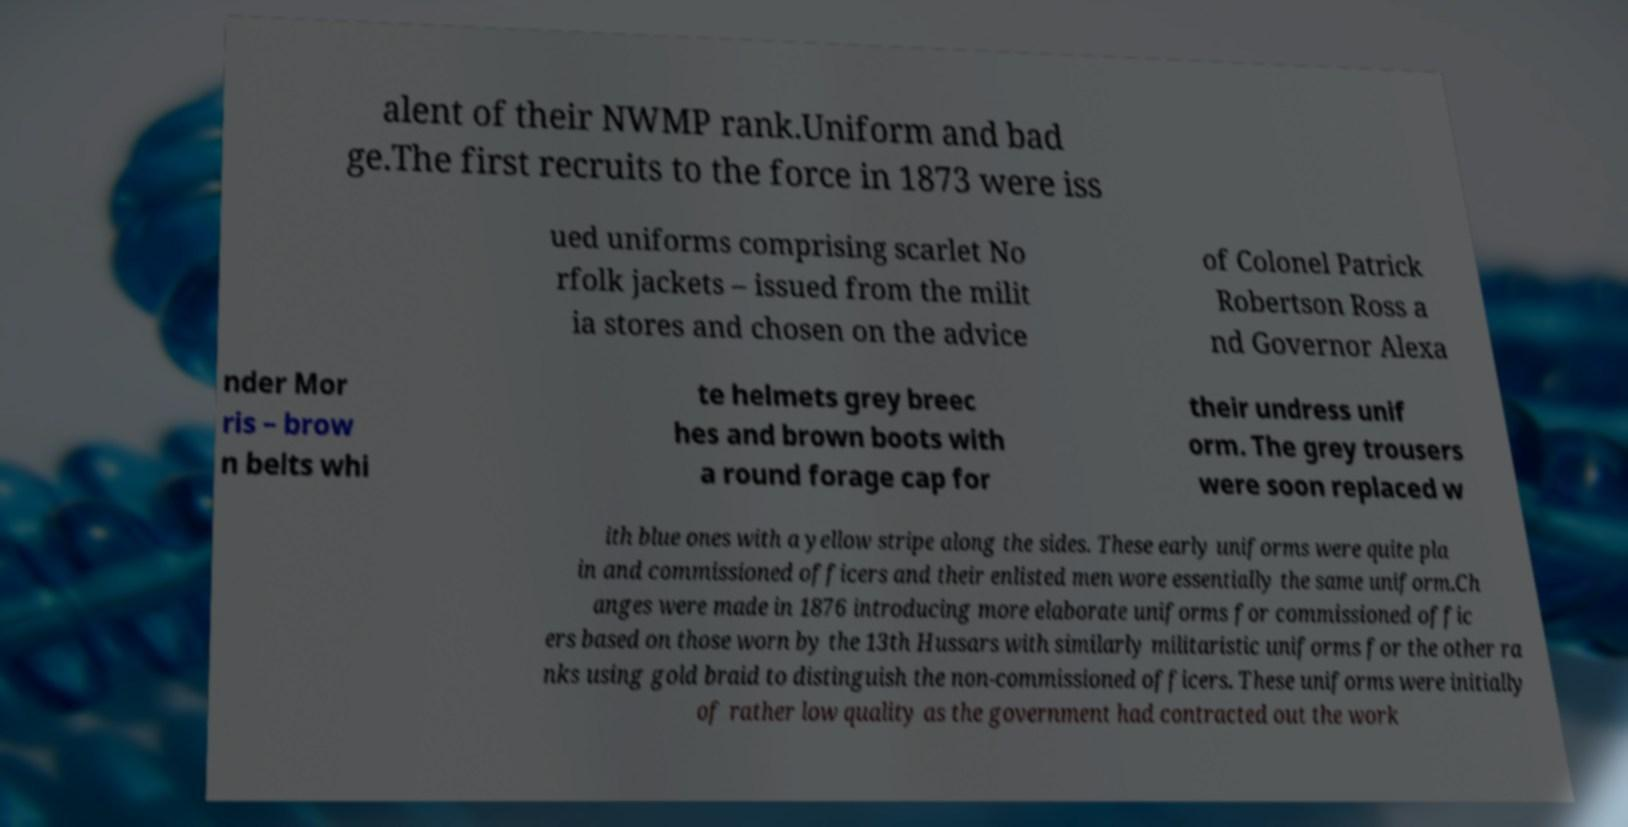For documentation purposes, I need the text within this image transcribed. Could you provide that? alent of their NWMP rank.Uniform and bad ge.The first recruits to the force in 1873 were iss ued uniforms comprising scarlet No rfolk jackets – issued from the milit ia stores and chosen on the advice of Colonel Patrick Robertson Ross a nd Governor Alexa nder Mor ris – brow n belts whi te helmets grey breec hes and brown boots with a round forage cap for their undress unif orm. The grey trousers were soon replaced w ith blue ones with a yellow stripe along the sides. These early uniforms were quite pla in and commissioned officers and their enlisted men wore essentially the same uniform.Ch anges were made in 1876 introducing more elaborate uniforms for commissioned offic ers based on those worn by the 13th Hussars with similarly militaristic uniforms for the other ra nks using gold braid to distinguish the non-commissioned officers. These uniforms were initially of rather low quality as the government had contracted out the work 